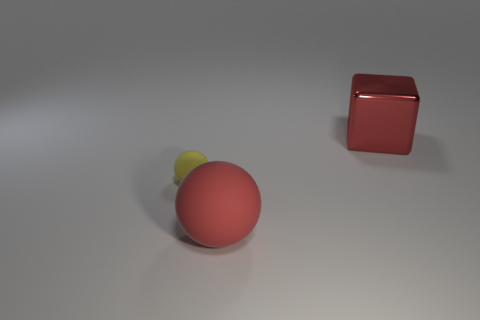What number of cyan things are metal objects or large spheres?
Provide a short and direct response. 0. How many other objects are the same size as the red rubber ball?
Your response must be concise. 1. What number of large objects are either rubber things or red shiny things?
Make the answer very short. 2. Do the red rubber object and the sphere that is to the left of the big matte thing have the same size?
Keep it short and to the point. No. How many other objects are there of the same shape as the large matte thing?
Offer a very short reply. 1. Are there any tiny green matte spheres?
Ensure brevity in your answer.  No. Are there fewer large metallic objects behind the big shiny thing than tiny spheres on the left side of the tiny rubber thing?
Ensure brevity in your answer.  No. There is a thing behind the small thing; what is its shape?
Keep it short and to the point. Cube. Is the small yellow object made of the same material as the big cube?
Provide a succinct answer. No. Are there any other things that are made of the same material as the big red block?
Provide a short and direct response. No. 